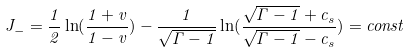<formula> <loc_0><loc_0><loc_500><loc_500>J _ { - } = \frac { 1 } { 2 } \ln ( \frac { 1 + v } { 1 - v } ) - \frac { 1 } { \sqrt { \Gamma - 1 } } \ln ( \frac { \sqrt { \Gamma - 1 } + c _ { s } } { \sqrt { \Gamma - 1 } - c _ { s } } ) = c o n s t</formula> 